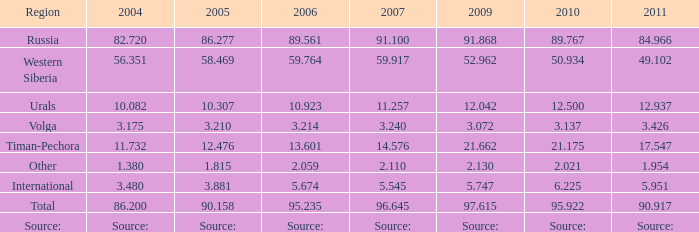What is the 2004 Lukoil oil prodroduction when in 2011 oil production 90.917 million tonnes? 86.2. Write the full table. {'header': ['Region', '2004', '2005', '2006', '2007', '2009', '2010', '2011'], 'rows': [['Russia', '82.720', '86.277', '89.561', '91.100', '91.868', '89.767', '84.966'], ['Western Siberia', '56.351', '58.469', '59.764', '59.917', '52.962', '50.934', '49.102'], ['Urals', '10.082', '10.307', '10.923', '11.257', '12.042', '12.500', '12.937'], ['Volga', '3.175', '3.210', '3.214', '3.240', '3.072', '3.137', '3.426'], ['Timan-Pechora', '11.732', '12.476', '13.601', '14.576', '21.662', '21.175', '17.547'], ['Other', '1.380', '1.815', '2.059', '2.110', '2.130', '2.021', '1.954'], ['International', '3.480', '3.881', '5.674', '5.545', '5.747', '6.225', '5.951'], ['Total', '86.200', '90.158', '95.235', '96.645', '97.615', '95.922', '90.917'], ['Source:', 'Source:', 'Source:', 'Source:', 'Source:', 'Source:', 'Source:', 'Source:']]} 